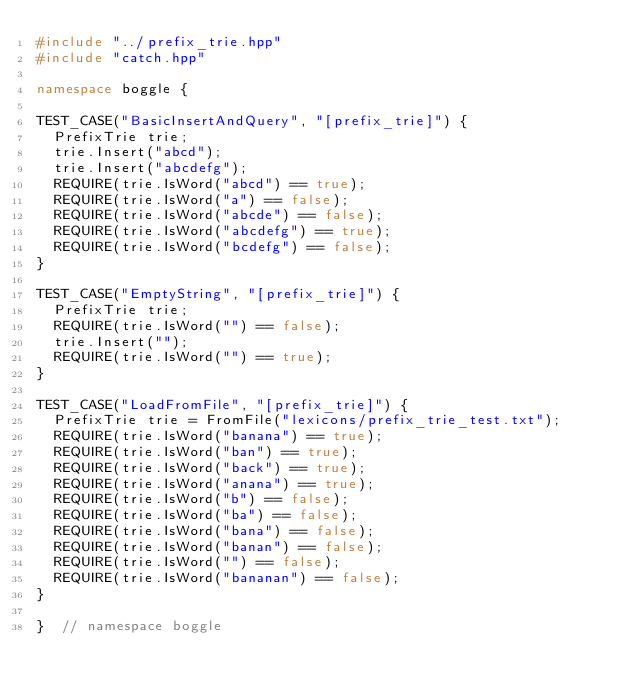Convert code to text. <code><loc_0><loc_0><loc_500><loc_500><_C++_>#include "../prefix_trie.hpp"
#include "catch.hpp"

namespace boggle {

TEST_CASE("BasicInsertAndQuery", "[prefix_trie]") {
  PrefixTrie trie;
  trie.Insert("abcd");
  trie.Insert("abcdefg");
  REQUIRE(trie.IsWord("abcd") == true);
  REQUIRE(trie.IsWord("a") == false);
  REQUIRE(trie.IsWord("abcde") == false);
  REQUIRE(trie.IsWord("abcdefg") == true);
  REQUIRE(trie.IsWord("bcdefg") == false);
}

TEST_CASE("EmptyString", "[prefix_trie]") {
  PrefixTrie trie;
  REQUIRE(trie.IsWord("") == false);
  trie.Insert("");
  REQUIRE(trie.IsWord("") == true);
}

TEST_CASE("LoadFromFile", "[prefix_trie]") {
  PrefixTrie trie = FromFile("lexicons/prefix_trie_test.txt");
  REQUIRE(trie.IsWord("banana") == true);
  REQUIRE(trie.IsWord("ban") == true);
  REQUIRE(trie.IsWord("back") == true);
  REQUIRE(trie.IsWord("anana") == true);
  REQUIRE(trie.IsWord("b") == false);
  REQUIRE(trie.IsWord("ba") == false);
  REQUIRE(trie.IsWord("bana") == false);
  REQUIRE(trie.IsWord("banan") == false);
  REQUIRE(trie.IsWord("") == false);
  REQUIRE(trie.IsWord("bananan") == false);
}

}  // namespace boggle
</code> 